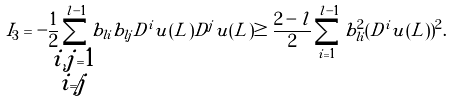Convert formula to latex. <formula><loc_0><loc_0><loc_500><loc_500>I _ { 3 } = - \frac { 1 } { 2 } \sum _ { \mathclap { \substack { i , j = 1 \\ i \neq j } } } ^ { l - 1 } b _ { l i } b _ { l j } D ^ { i } u ( L ) D ^ { j } u ( L ) \geq \frac { 2 - l } { 2 } \sum _ { i = 1 } ^ { l - 1 } b _ { l i } ^ { 2 } ( D ^ { i } u ( L ) ) ^ { 2 } .</formula> 